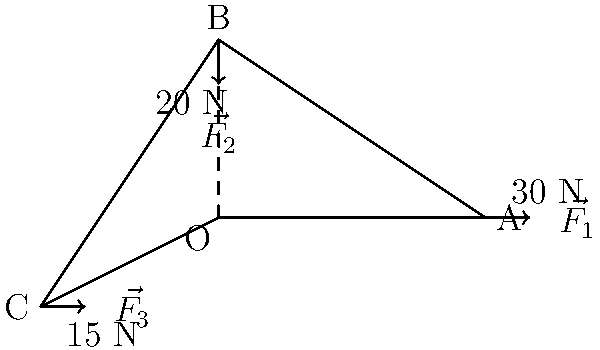In the mechanical joint prototype shown above, three force vectors $\vec{F_1}$, $\vec{F_2}$, and $\vec{F_3}$ are applied at points A, B, and C respectively. Given that $\vec{F_1} = 30$ N, $\vec{F_2} = 20$ N, and $\vec{F_3} = 15$ N, calculate the magnitude of the total torque applied to the joint at point O. To calculate the total torque, we need to follow these steps:

1) Torque is calculated using the formula: $\tau = r \times F$, where $r$ is the position vector from the point of rotation to the point of force application.

2) We need to calculate the torque for each force and then sum them up:

   For $\vec{F_1}$:
   $r_1 = (3, 0)$
   $\tau_1 = (3 \times 0 - 0 \times 30) = 0$ N⋅m

   For $\vec{F_2}$:
   $r_2 = (0, 2)$
   $\tau_2 = (0 \times (-20) - 2 \times 0) = 0$ N⋅m

   For $\vec{F_3}$:
   $r_3 = (-2, -1)$
   $\tau_3 = (-2 \times 0 - (-1) \times 15) = 15$ N⋅m

3) The total torque is the sum of these individual torques:

   $\tau_{total} = \tau_1 + \tau_2 + \tau_3 = 0 + 0 + 15 = 15$ N⋅m

4) The magnitude of the total torque is the absolute value of this sum:

   $|\tau_{total}| = |15| = 15$ N⋅m
Answer: 15 N⋅m 